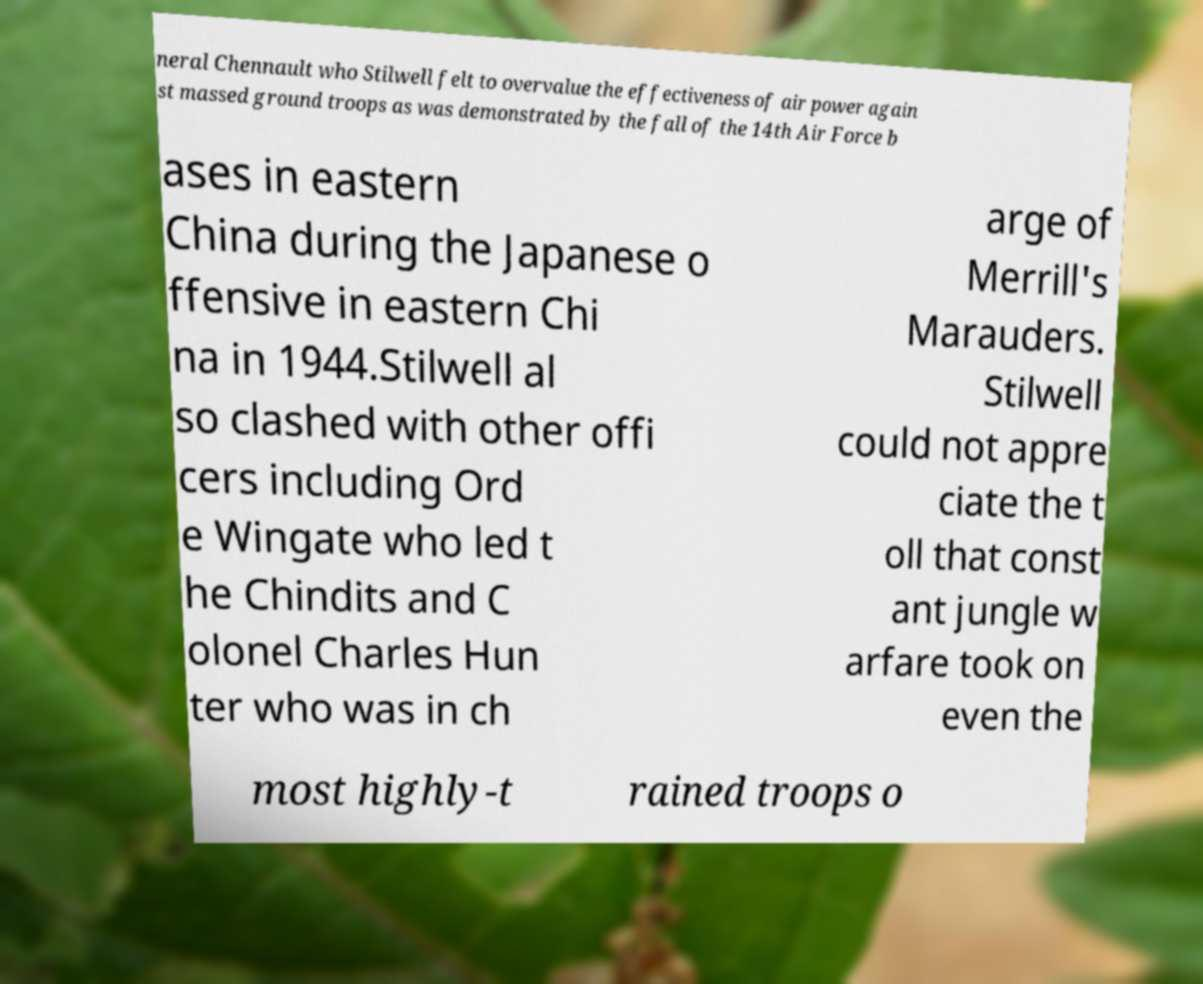Could you assist in decoding the text presented in this image and type it out clearly? neral Chennault who Stilwell felt to overvalue the effectiveness of air power again st massed ground troops as was demonstrated by the fall of the 14th Air Force b ases in eastern China during the Japanese o ffensive in eastern Chi na in 1944.Stilwell al so clashed with other offi cers including Ord e Wingate who led t he Chindits and C olonel Charles Hun ter who was in ch arge of Merrill's Marauders. Stilwell could not appre ciate the t oll that const ant jungle w arfare took on even the most highly-t rained troops o 